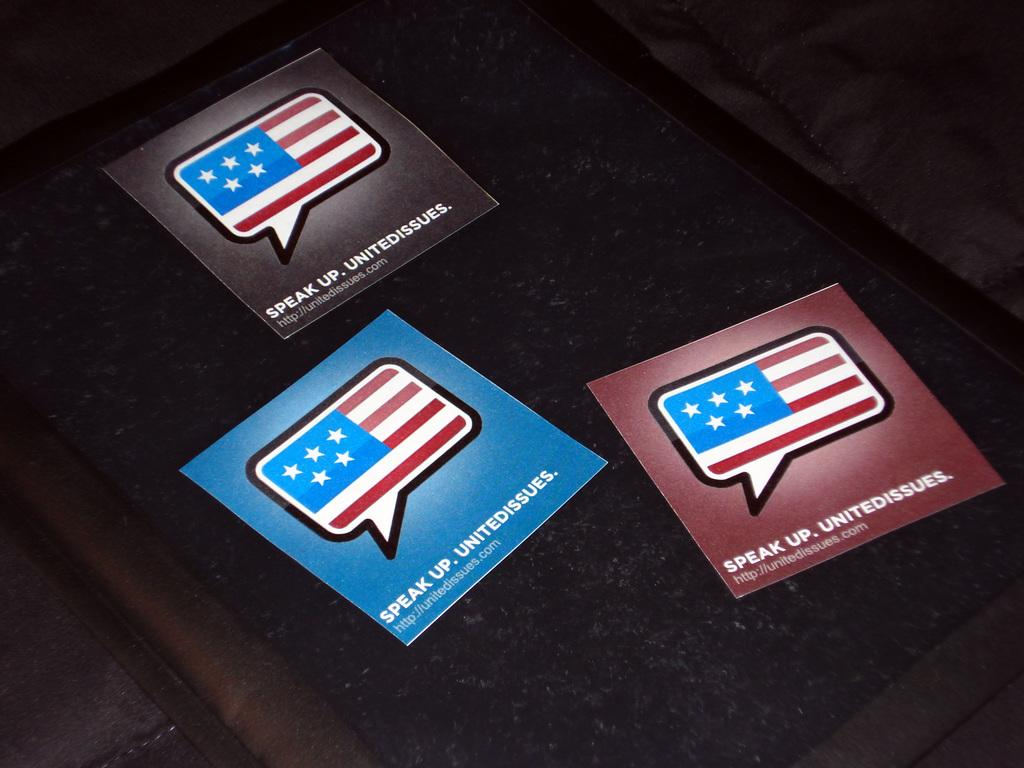What is on the board in the image? There are papers on a board in the image. How many roses are present on the board in the image? There are no roses present on the board in the image. 